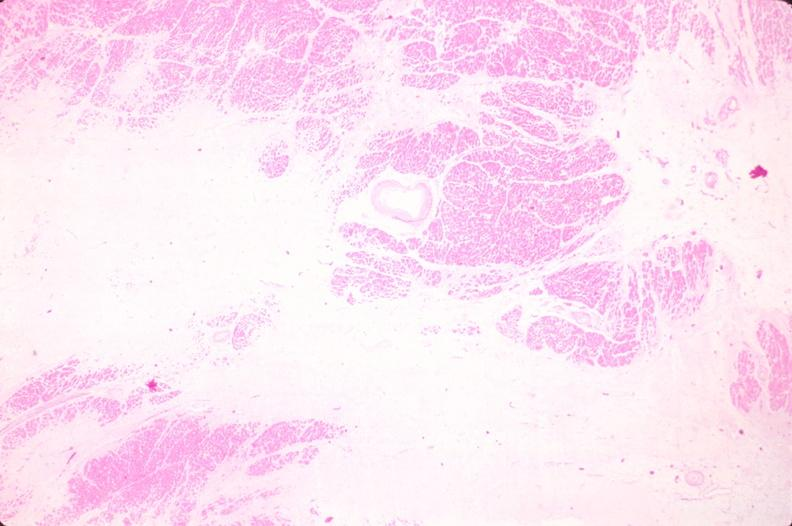does pus in test tube show heart, old myocardial infarction with fibrosis, he?
Answer the question using a single word or phrase. No 